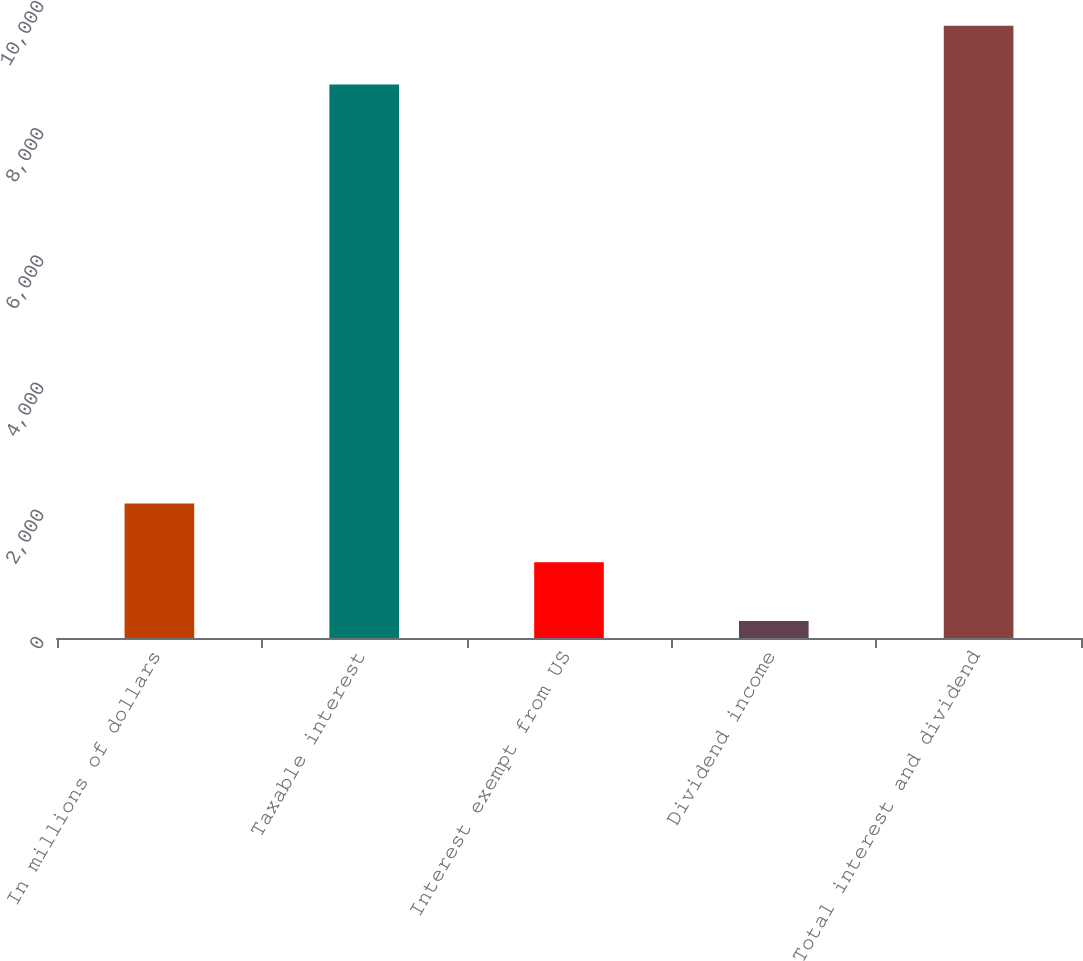Convert chart. <chart><loc_0><loc_0><loc_500><loc_500><bar_chart><fcel>In millions of dollars<fcel>Taxable interest<fcel>Interest exempt from US<fcel>Dividend income<fcel>Total interest and dividend<nl><fcel>2114<fcel>8704<fcel>1191.5<fcel>269<fcel>9626.5<nl></chart> 